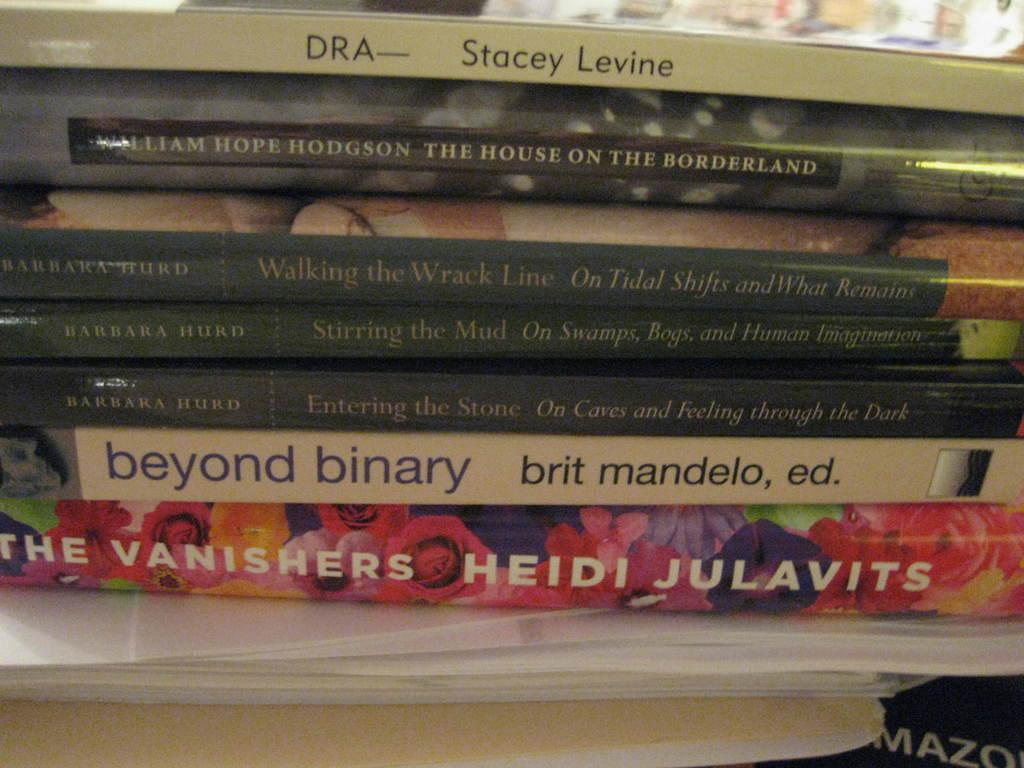Provide a one-sentence caption for the provided image. A colorful book titled The Vanishers by Heidi Julavits sits at the bottom of a stack of books. 